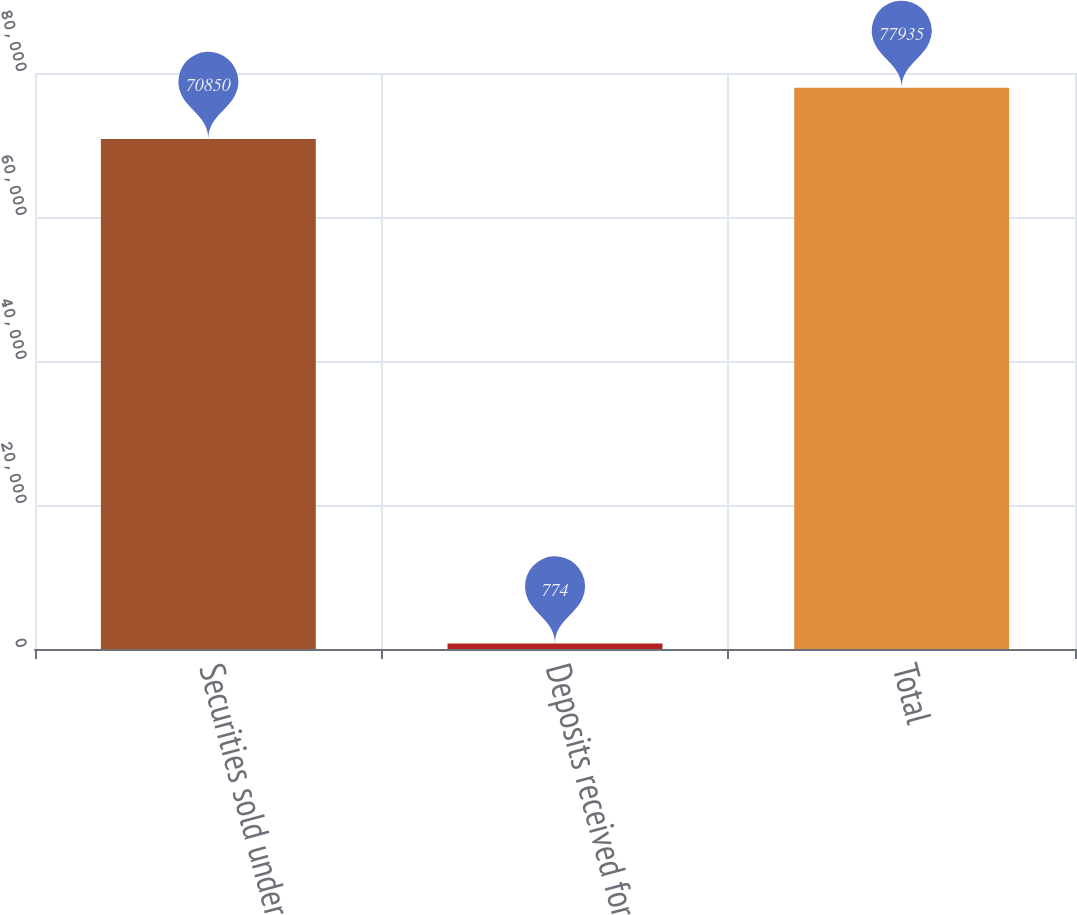Convert chart. <chart><loc_0><loc_0><loc_500><loc_500><bar_chart><fcel>Securities sold under<fcel>Deposits received for<fcel>Total<nl><fcel>70850<fcel>774<fcel>77935<nl></chart> 